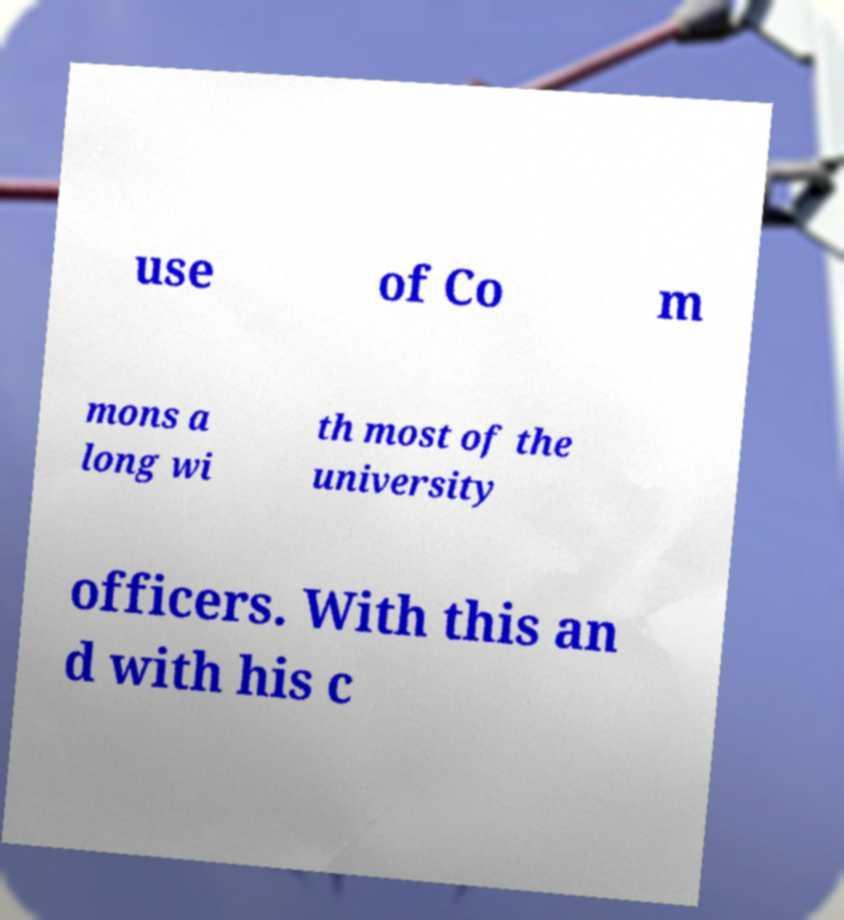Can you accurately transcribe the text from the provided image for me? use of Co m mons a long wi th most of the university officers. With this an d with his c 